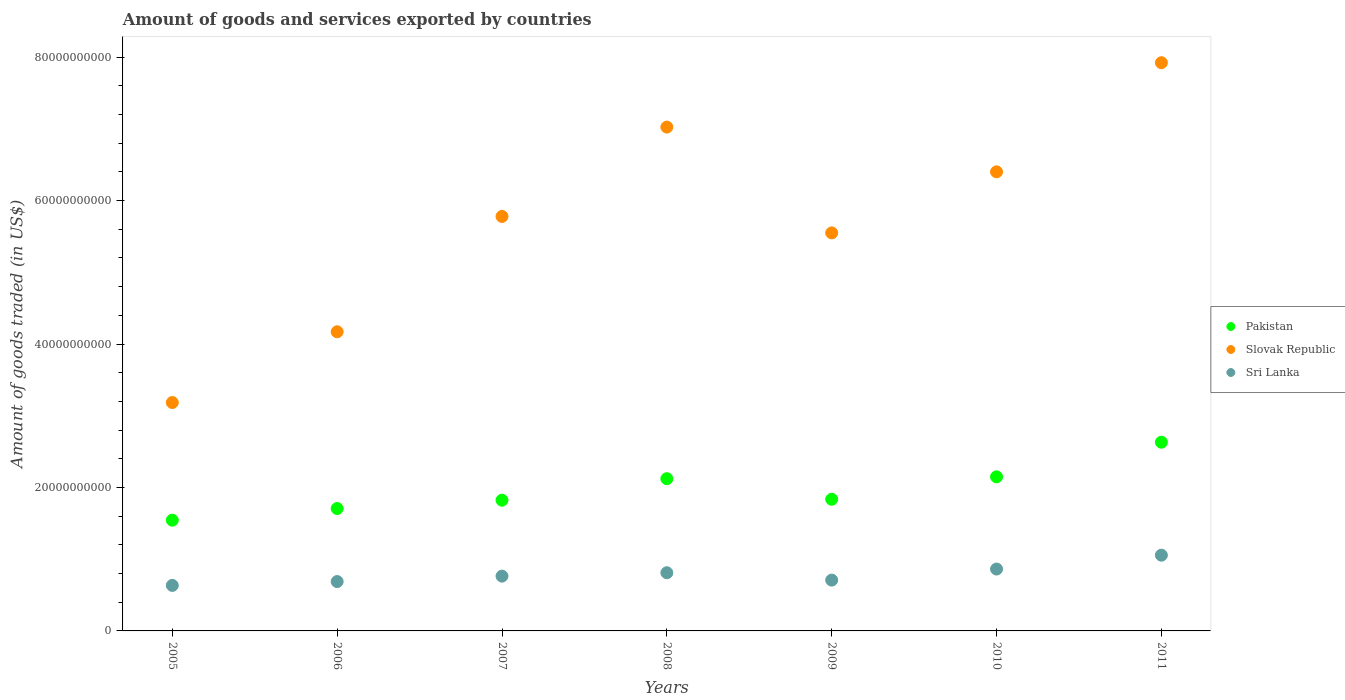How many different coloured dotlines are there?
Ensure brevity in your answer.  3. Is the number of dotlines equal to the number of legend labels?
Make the answer very short. Yes. What is the total amount of goods and services exported in Slovak Republic in 2007?
Provide a succinct answer. 5.78e+1. Across all years, what is the maximum total amount of goods and services exported in Slovak Republic?
Provide a succinct answer. 7.92e+1. Across all years, what is the minimum total amount of goods and services exported in Sri Lanka?
Your answer should be compact. 6.35e+09. In which year was the total amount of goods and services exported in Pakistan maximum?
Your response must be concise. 2011. In which year was the total amount of goods and services exported in Sri Lanka minimum?
Provide a short and direct response. 2005. What is the total total amount of goods and services exported in Sri Lanka in the graph?
Make the answer very short. 5.52e+1. What is the difference between the total amount of goods and services exported in Sri Lanka in 2005 and that in 2010?
Make the answer very short. -2.28e+09. What is the difference between the total amount of goods and services exported in Pakistan in 2008 and the total amount of goods and services exported in Sri Lanka in 2007?
Give a very brief answer. 1.36e+1. What is the average total amount of goods and services exported in Slovak Republic per year?
Offer a terse response. 5.72e+1. In the year 2009, what is the difference between the total amount of goods and services exported in Slovak Republic and total amount of goods and services exported in Pakistan?
Your answer should be compact. 3.71e+1. What is the ratio of the total amount of goods and services exported in Pakistan in 2007 to that in 2008?
Ensure brevity in your answer.  0.86. What is the difference between the highest and the second highest total amount of goods and services exported in Sri Lanka?
Offer a terse response. 1.93e+09. What is the difference between the highest and the lowest total amount of goods and services exported in Slovak Republic?
Provide a succinct answer. 4.74e+1. Is the sum of the total amount of goods and services exported in Slovak Republic in 2008 and 2009 greater than the maximum total amount of goods and services exported in Sri Lanka across all years?
Your answer should be compact. Yes. Is it the case that in every year, the sum of the total amount of goods and services exported in Sri Lanka and total amount of goods and services exported in Pakistan  is greater than the total amount of goods and services exported in Slovak Republic?
Offer a terse response. No. Does the total amount of goods and services exported in Pakistan monotonically increase over the years?
Offer a very short reply. No. Is the total amount of goods and services exported in Sri Lanka strictly less than the total amount of goods and services exported in Slovak Republic over the years?
Provide a succinct answer. Yes. Does the graph contain any zero values?
Offer a very short reply. No. Where does the legend appear in the graph?
Provide a succinct answer. Center right. How many legend labels are there?
Your response must be concise. 3. How are the legend labels stacked?
Ensure brevity in your answer.  Vertical. What is the title of the graph?
Offer a very short reply. Amount of goods and services exported by countries. Does "Puerto Rico" appear as one of the legend labels in the graph?
Your answer should be compact. No. What is the label or title of the X-axis?
Offer a terse response. Years. What is the label or title of the Y-axis?
Offer a terse response. Amount of goods traded (in US$). What is the Amount of goods traded (in US$) in Pakistan in 2005?
Provide a short and direct response. 1.54e+1. What is the Amount of goods traded (in US$) in Slovak Republic in 2005?
Make the answer very short. 3.18e+1. What is the Amount of goods traded (in US$) in Sri Lanka in 2005?
Offer a very short reply. 6.35e+09. What is the Amount of goods traded (in US$) in Pakistan in 2006?
Ensure brevity in your answer.  1.71e+1. What is the Amount of goods traded (in US$) of Slovak Republic in 2006?
Offer a terse response. 4.17e+1. What is the Amount of goods traded (in US$) in Sri Lanka in 2006?
Offer a very short reply. 6.88e+09. What is the Amount of goods traded (in US$) in Pakistan in 2007?
Provide a succinct answer. 1.82e+1. What is the Amount of goods traded (in US$) in Slovak Republic in 2007?
Your answer should be very brief. 5.78e+1. What is the Amount of goods traded (in US$) of Sri Lanka in 2007?
Make the answer very short. 7.64e+09. What is the Amount of goods traded (in US$) in Pakistan in 2008?
Offer a terse response. 2.12e+1. What is the Amount of goods traded (in US$) in Slovak Republic in 2008?
Keep it short and to the point. 7.02e+1. What is the Amount of goods traded (in US$) in Sri Lanka in 2008?
Your answer should be compact. 8.11e+09. What is the Amount of goods traded (in US$) of Pakistan in 2009?
Provide a short and direct response. 1.84e+1. What is the Amount of goods traded (in US$) of Slovak Republic in 2009?
Provide a short and direct response. 5.55e+1. What is the Amount of goods traded (in US$) of Sri Lanka in 2009?
Ensure brevity in your answer.  7.08e+09. What is the Amount of goods traded (in US$) of Pakistan in 2010?
Your answer should be very brief. 2.15e+1. What is the Amount of goods traded (in US$) in Slovak Republic in 2010?
Ensure brevity in your answer.  6.40e+1. What is the Amount of goods traded (in US$) in Sri Lanka in 2010?
Ensure brevity in your answer.  8.63e+09. What is the Amount of goods traded (in US$) in Pakistan in 2011?
Your answer should be very brief. 2.63e+1. What is the Amount of goods traded (in US$) in Slovak Republic in 2011?
Your answer should be compact. 7.92e+1. What is the Amount of goods traded (in US$) of Sri Lanka in 2011?
Your answer should be compact. 1.06e+1. Across all years, what is the maximum Amount of goods traded (in US$) in Pakistan?
Offer a very short reply. 2.63e+1. Across all years, what is the maximum Amount of goods traded (in US$) in Slovak Republic?
Offer a terse response. 7.92e+1. Across all years, what is the maximum Amount of goods traded (in US$) of Sri Lanka?
Offer a terse response. 1.06e+1. Across all years, what is the minimum Amount of goods traded (in US$) in Pakistan?
Ensure brevity in your answer.  1.54e+1. Across all years, what is the minimum Amount of goods traded (in US$) in Slovak Republic?
Give a very brief answer. 3.18e+1. Across all years, what is the minimum Amount of goods traded (in US$) of Sri Lanka?
Offer a very short reply. 6.35e+09. What is the total Amount of goods traded (in US$) of Pakistan in the graph?
Provide a succinct answer. 1.38e+11. What is the total Amount of goods traded (in US$) in Slovak Republic in the graph?
Ensure brevity in your answer.  4.00e+11. What is the total Amount of goods traded (in US$) in Sri Lanka in the graph?
Make the answer very short. 5.52e+1. What is the difference between the Amount of goods traded (in US$) in Pakistan in 2005 and that in 2006?
Your answer should be compact. -1.63e+09. What is the difference between the Amount of goods traded (in US$) in Slovak Republic in 2005 and that in 2006?
Provide a succinct answer. -9.86e+09. What is the difference between the Amount of goods traded (in US$) of Sri Lanka in 2005 and that in 2006?
Make the answer very short. -5.36e+08. What is the difference between the Amount of goods traded (in US$) of Pakistan in 2005 and that in 2007?
Give a very brief answer. -2.79e+09. What is the difference between the Amount of goods traded (in US$) of Slovak Republic in 2005 and that in 2007?
Provide a succinct answer. -2.59e+1. What is the difference between the Amount of goods traded (in US$) of Sri Lanka in 2005 and that in 2007?
Keep it short and to the point. -1.29e+09. What is the difference between the Amount of goods traded (in US$) in Pakistan in 2005 and that in 2008?
Your answer should be very brief. -5.79e+09. What is the difference between the Amount of goods traded (in US$) in Slovak Republic in 2005 and that in 2008?
Make the answer very short. -3.84e+1. What is the difference between the Amount of goods traded (in US$) in Sri Lanka in 2005 and that in 2008?
Offer a terse response. -1.76e+09. What is the difference between the Amount of goods traded (in US$) of Pakistan in 2005 and that in 2009?
Give a very brief answer. -2.92e+09. What is the difference between the Amount of goods traded (in US$) of Slovak Republic in 2005 and that in 2009?
Provide a succinct answer. -2.36e+1. What is the difference between the Amount of goods traded (in US$) in Sri Lanka in 2005 and that in 2009?
Your answer should be very brief. -7.38e+08. What is the difference between the Amount of goods traded (in US$) in Pakistan in 2005 and that in 2010?
Provide a short and direct response. -6.04e+09. What is the difference between the Amount of goods traded (in US$) of Slovak Republic in 2005 and that in 2010?
Give a very brief answer. -3.22e+1. What is the difference between the Amount of goods traded (in US$) of Sri Lanka in 2005 and that in 2010?
Ensure brevity in your answer.  -2.28e+09. What is the difference between the Amount of goods traded (in US$) in Pakistan in 2005 and that in 2011?
Give a very brief answer. -1.09e+1. What is the difference between the Amount of goods traded (in US$) in Slovak Republic in 2005 and that in 2011?
Your answer should be very brief. -4.74e+1. What is the difference between the Amount of goods traded (in US$) in Sri Lanka in 2005 and that in 2011?
Offer a very short reply. -4.21e+09. What is the difference between the Amount of goods traded (in US$) in Pakistan in 2006 and that in 2007?
Give a very brief answer. -1.16e+09. What is the difference between the Amount of goods traded (in US$) of Slovak Republic in 2006 and that in 2007?
Give a very brief answer. -1.61e+1. What is the difference between the Amount of goods traded (in US$) in Sri Lanka in 2006 and that in 2007?
Your answer should be very brief. -7.57e+08. What is the difference between the Amount of goods traded (in US$) of Pakistan in 2006 and that in 2008?
Keep it short and to the point. -4.16e+09. What is the difference between the Amount of goods traded (in US$) in Slovak Republic in 2006 and that in 2008?
Give a very brief answer. -2.85e+1. What is the difference between the Amount of goods traded (in US$) of Sri Lanka in 2006 and that in 2008?
Ensure brevity in your answer.  -1.23e+09. What is the difference between the Amount of goods traded (in US$) of Pakistan in 2006 and that in 2009?
Give a very brief answer. -1.29e+09. What is the difference between the Amount of goods traded (in US$) of Slovak Republic in 2006 and that in 2009?
Ensure brevity in your answer.  -1.38e+1. What is the difference between the Amount of goods traded (in US$) of Sri Lanka in 2006 and that in 2009?
Offer a very short reply. -2.02e+08. What is the difference between the Amount of goods traded (in US$) in Pakistan in 2006 and that in 2010?
Your answer should be compact. -4.42e+09. What is the difference between the Amount of goods traded (in US$) of Slovak Republic in 2006 and that in 2010?
Your response must be concise. -2.23e+1. What is the difference between the Amount of goods traded (in US$) in Sri Lanka in 2006 and that in 2010?
Your answer should be very brief. -1.74e+09. What is the difference between the Amount of goods traded (in US$) of Pakistan in 2006 and that in 2011?
Your answer should be compact. -9.24e+09. What is the difference between the Amount of goods traded (in US$) of Slovak Republic in 2006 and that in 2011?
Make the answer very short. -3.75e+1. What is the difference between the Amount of goods traded (in US$) in Sri Lanka in 2006 and that in 2011?
Your answer should be compact. -3.68e+09. What is the difference between the Amount of goods traded (in US$) of Pakistan in 2007 and that in 2008?
Your response must be concise. -3.00e+09. What is the difference between the Amount of goods traded (in US$) of Slovak Republic in 2007 and that in 2008?
Your response must be concise. -1.25e+1. What is the difference between the Amount of goods traded (in US$) in Sri Lanka in 2007 and that in 2008?
Provide a short and direct response. -4.71e+08. What is the difference between the Amount of goods traded (in US$) of Pakistan in 2007 and that in 2009?
Keep it short and to the point. -1.33e+08. What is the difference between the Amount of goods traded (in US$) of Slovak Republic in 2007 and that in 2009?
Ensure brevity in your answer.  2.30e+09. What is the difference between the Amount of goods traded (in US$) in Sri Lanka in 2007 and that in 2009?
Keep it short and to the point. 5.55e+08. What is the difference between the Amount of goods traded (in US$) in Pakistan in 2007 and that in 2010?
Make the answer very short. -3.26e+09. What is the difference between the Amount of goods traded (in US$) of Slovak Republic in 2007 and that in 2010?
Your response must be concise. -6.22e+09. What is the difference between the Amount of goods traded (in US$) in Sri Lanka in 2007 and that in 2010?
Your answer should be very brief. -9.86e+08. What is the difference between the Amount of goods traded (in US$) in Pakistan in 2007 and that in 2011?
Offer a terse response. -8.08e+09. What is the difference between the Amount of goods traded (in US$) of Slovak Republic in 2007 and that in 2011?
Provide a succinct answer. -2.14e+1. What is the difference between the Amount of goods traded (in US$) of Sri Lanka in 2007 and that in 2011?
Make the answer very short. -2.92e+09. What is the difference between the Amount of goods traded (in US$) of Pakistan in 2008 and that in 2009?
Your answer should be compact. 2.87e+09. What is the difference between the Amount of goods traded (in US$) in Slovak Republic in 2008 and that in 2009?
Keep it short and to the point. 1.48e+1. What is the difference between the Amount of goods traded (in US$) of Sri Lanka in 2008 and that in 2009?
Provide a succinct answer. 1.03e+09. What is the difference between the Amount of goods traded (in US$) in Pakistan in 2008 and that in 2010?
Provide a succinct answer. -2.58e+08. What is the difference between the Amount of goods traded (in US$) of Slovak Republic in 2008 and that in 2010?
Keep it short and to the point. 6.24e+09. What is the difference between the Amount of goods traded (in US$) of Sri Lanka in 2008 and that in 2010?
Your answer should be very brief. -5.15e+08. What is the difference between the Amount of goods traded (in US$) of Pakistan in 2008 and that in 2011?
Provide a succinct answer. -5.08e+09. What is the difference between the Amount of goods traded (in US$) of Slovak Republic in 2008 and that in 2011?
Ensure brevity in your answer.  -8.98e+09. What is the difference between the Amount of goods traded (in US$) in Sri Lanka in 2008 and that in 2011?
Give a very brief answer. -2.45e+09. What is the difference between the Amount of goods traded (in US$) in Pakistan in 2009 and that in 2010?
Provide a short and direct response. -3.12e+09. What is the difference between the Amount of goods traded (in US$) of Slovak Republic in 2009 and that in 2010?
Offer a terse response. -8.51e+09. What is the difference between the Amount of goods traded (in US$) in Sri Lanka in 2009 and that in 2010?
Your answer should be very brief. -1.54e+09. What is the difference between the Amount of goods traded (in US$) of Pakistan in 2009 and that in 2011?
Make the answer very short. -7.95e+09. What is the difference between the Amount of goods traded (in US$) of Slovak Republic in 2009 and that in 2011?
Offer a terse response. -2.37e+1. What is the difference between the Amount of goods traded (in US$) of Sri Lanka in 2009 and that in 2011?
Provide a short and direct response. -3.47e+09. What is the difference between the Amount of goods traded (in US$) of Pakistan in 2010 and that in 2011?
Give a very brief answer. -4.83e+09. What is the difference between the Amount of goods traded (in US$) of Slovak Republic in 2010 and that in 2011?
Offer a very short reply. -1.52e+1. What is the difference between the Amount of goods traded (in US$) in Sri Lanka in 2010 and that in 2011?
Make the answer very short. -1.93e+09. What is the difference between the Amount of goods traded (in US$) of Pakistan in 2005 and the Amount of goods traded (in US$) of Slovak Republic in 2006?
Keep it short and to the point. -2.63e+1. What is the difference between the Amount of goods traded (in US$) of Pakistan in 2005 and the Amount of goods traded (in US$) of Sri Lanka in 2006?
Your answer should be very brief. 8.56e+09. What is the difference between the Amount of goods traded (in US$) of Slovak Republic in 2005 and the Amount of goods traded (in US$) of Sri Lanka in 2006?
Your answer should be very brief. 2.50e+1. What is the difference between the Amount of goods traded (in US$) in Pakistan in 2005 and the Amount of goods traded (in US$) in Slovak Republic in 2007?
Provide a succinct answer. -4.23e+1. What is the difference between the Amount of goods traded (in US$) of Pakistan in 2005 and the Amount of goods traded (in US$) of Sri Lanka in 2007?
Keep it short and to the point. 7.80e+09. What is the difference between the Amount of goods traded (in US$) of Slovak Republic in 2005 and the Amount of goods traded (in US$) of Sri Lanka in 2007?
Give a very brief answer. 2.42e+1. What is the difference between the Amount of goods traded (in US$) in Pakistan in 2005 and the Amount of goods traded (in US$) in Slovak Republic in 2008?
Offer a very short reply. -5.48e+1. What is the difference between the Amount of goods traded (in US$) of Pakistan in 2005 and the Amount of goods traded (in US$) of Sri Lanka in 2008?
Give a very brief answer. 7.33e+09. What is the difference between the Amount of goods traded (in US$) in Slovak Republic in 2005 and the Amount of goods traded (in US$) in Sri Lanka in 2008?
Offer a terse response. 2.37e+1. What is the difference between the Amount of goods traded (in US$) in Pakistan in 2005 and the Amount of goods traded (in US$) in Slovak Republic in 2009?
Your answer should be compact. -4.01e+1. What is the difference between the Amount of goods traded (in US$) in Pakistan in 2005 and the Amount of goods traded (in US$) in Sri Lanka in 2009?
Your answer should be very brief. 8.35e+09. What is the difference between the Amount of goods traded (in US$) of Slovak Republic in 2005 and the Amount of goods traded (in US$) of Sri Lanka in 2009?
Make the answer very short. 2.48e+1. What is the difference between the Amount of goods traded (in US$) in Pakistan in 2005 and the Amount of goods traded (in US$) in Slovak Republic in 2010?
Offer a very short reply. -4.86e+1. What is the difference between the Amount of goods traded (in US$) in Pakistan in 2005 and the Amount of goods traded (in US$) in Sri Lanka in 2010?
Offer a terse response. 6.81e+09. What is the difference between the Amount of goods traded (in US$) of Slovak Republic in 2005 and the Amount of goods traded (in US$) of Sri Lanka in 2010?
Ensure brevity in your answer.  2.32e+1. What is the difference between the Amount of goods traded (in US$) of Pakistan in 2005 and the Amount of goods traded (in US$) of Slovak Republic in 2011?
Your response must be concise. -6.38e+1. What is the difference between the Amount of goods traded (in US$) in Pakistan in 2005 and the Amount of goods traded (in US$) in Sri Lanka in 2011?
Provide a succinct answer. 4.88e+09. What is the difference between the Amount of goods traded (in US$) of Slovak Republic in 2005 and the Amount of goods traded (in US$) of Sri Lanka in 2011?
Your response must be concise. 2.13e+1. What is the difference between the Amount of goods traded (in US$) of Pakistan in 2006 and the Amount of goods traded (in US$) of Slovak Republic in 2007?
Provide a short and direct response. -4.07e+1. What is the difference between the Amount of goods traded (in US$) in Pakistan in 2006 and the Amount of goods traded (in US$) in Sri Lanka in 2007?
Provide a short and direct response. 9.42e+09. What is the difference between the Amount of goods traded (in US$) in Slovak Republic in 2006 and the Amount of goods traded (in US$) in Sri Lanka in 2007?
Give a very brief answer. 3.41e+1. What is the difference between the Amount of goods traded (in US$) in Pakistan in 2006 and the Amount of goods traded (in US$) in Slovak Republic in 2008?
Your answer should be compact. -5.32e+1. What is the difference between the Amount of goods traded (in US$) in Pakistan in 2006 and the Amount of goods traded (in US$) in Sri Lanka in 2008?
Your response must be concise. 8.95e+09. What is the difference between the Amount of goods traded (in US$) in Slovak Republic in 2006 and the Amount of goods traded (in US$) in Sri Lanka in 2008?
Your answer should be very brief. 3.36e+1. What is the difference between the Amount of goods traded (in US$) of Pakistan in 2006 and the Amount of goods traded (in US$) of Slovak Republic in 2009?
Offer a very short reply. -3.84e+1. What is the difference between the Amount of goods traded (in US$) of Pakistan in 2006 and the Amount of goods traded (in US$) of Sri Lanka in 2009?
Provide a succinct answer. 9.98e+09. What is the difference between the Amount of goods traded (in US$) of Slovak Republic in 2006 and the Amount of goods traded (in US$) of Sri Lanka in 2009?
Offer a very short reply. 3.46e+1. What is the difference between the Amount of goods traded (in US$) of Pakistan in 2006 and the Amount of goods traded (in US$) of Slovak Republic in 2010?
Give a very brief answer. -4.69e+1. What is the difference between the Amount of goods traded (in US$) in Pakistan in 2006 and the Amount of goods traded (in US$) in Sri Lanka in 2010?
Provide a short and direct response. 8.44e+09. What is the difference between the Amount of goods traded (in US$) of Slovak Republic in 2006 and the Amount of goods traded (in US$) of Sri Lanka in 2010?
Give a very brief answer. 3.31e+1. What is the difference between the Amount of goods traded (in US$) of Pakistan in 2006 and the Amount of goods traded (in US$) of Slovak Republic in 2011?
Ensure brevity in your answer.  -6.22e+1. What is the difference between the Amount of goods traded (in US$) of Pakistan in 2006 and the Amount of goods traded (in US$) of Sri Lanka in 2011?
Offer a very short reply. 6.51e+09. What is the difference between the Amount of goods traded (in US$) in Slovak Republic in 2006 and the Amount of goods traded (in US$) in Sri Lanka in 2011?
Provide a succinct answer. 3.11e+1. What is the difference between the Amount of goods traded (in US$) of Pakistan in 2007 and the Amount of goods traded (in US$) of Slovak Republic in 2008?
Your response must be concise. -5.20e+1. What is the difference between the Amount of goods traded (in US$) in Pakistan in 2007 and the Amount of goods traded (in US$) in Sri Lanka in 2008?
Keep it short and to the point. 1.01e+1. What is the difference between the Amount of goods traded (in US$) of Slovak Republic in 2007 and the Amount of goods traded (in US$) of Sri Lanka in 2008?
Offer a very short reply. 4.97e+1. What is the difference between the Amount of goods traded (in US$) in Pakistan in 2007 and the Amount of goods traded (in US$) in Slovak Republic in 2009?
Your answer should be very brief. -3.73e+1. What is the difference between the Amount of goods traded (in US$) of Pakistan in 2007 and the Amount of goods traded (in US$) of Sri Lanka in 2009?
Keep it short and to the point. 1.11e+1. What is the difference between the Amount of goods traded (in US$) in Slovak Republic in 2007 and the Amount of goods traded (in US$) in Sri Lanka in 2009?
Your response must be concise. 5.07e+1. What is the difference between the Amount of goods traded (in US$) in Pakistan in 2007 and the Amount of goods traded (in US$) in Slovak Republic in 2010?
Offer a very short reply. -4.58e+1. What is the difference between the Amount of goods traded (in US$) of Pakistan in 2007 and the Amount of goods traded (in US$) of Sri Lanka in 2010?
Your answer should be compact. 9.60e+09. What is the difference between the Amount of goods traded (in US$) of Slovak Republic in 2007 and the Amount of goods traded (in US$) of Sri Lanka in 2010?
Provide a short and direct response. 4.92e+1. What is the difference between the Amount of goods traded (in US$) of Pakistan in 2007 and the Amount of goods traded (in US$) of Slovak Republic in 2011?
Offer a very short reply. -6.10e+1. What is the difference between the Amount of goods traded (in US$) in Pakistan in 2007 and the Amount of goods traded (in US$) in Sri Lanka in 2011?
Your answer should be compact. 7.67e+09. What is the difference between the Amount of goods traded (in US$) of Slovak Republic in 2007 and the Amount of goods traded (in US$) of Sri Lanka in 2011?
Your answer should be very brief. 4.72e+1. What is the difference between the Amount of goods traded (in US$) in Pakistan in 2008 and the Amount of goods traded (in US$) in Slovak Republic in 2009?
Keep it short and to the point. -3.43e+1. What is the difference between the Amount of goods traded (in US$) in Pakistan in 2008 and the Amount of goods traded (in US$) in Sri Lanka in 2009?
Offer a terse response. 1.41e+1. What is the difference between the Amount of goods traded (in US$) in Slovak Republic in 2008 and the Amount of goods traded (in US$) in Sri Lanka in 2009?
Keep it short and to the point. 6.32e+1. What is the difference between the Amount of goods traded (in US$) in Pakistan in 2008 and the Amount of goods traded (in US$) in Slovak Republic in 2010?
Your answer should be very brief. -4.28e+1. What is the difference between the Amount of goods traded (in US$) in Pakistan in 2008 and the Amount of goods traded (in US$) in Sri Lanka in 2010?
Your answer should be compact. 1.26e+1. What is the difference between the Amount of goods traded (in US$) in Slovak Republic in 2008 and the Amount of goods traded (in US$) in Sri Lanka in 2010?
Provide a short and direct response. 6.16e+1. What is the difference between the Amount of goods traded (in US$) in Pakistan in 2008 and the Amount of goods traded (in US$) in Slovak Republic in 2011?
Ensure brevity in your answer.  -5.80e+1. What is the difference between the Amount of goods traded (in US$) of Pakistan in 2008 and the Amount of goods traded (in US$) of Sri Lanka in 2011?
Your answer should be compact. 1.07e+1. What is the difference between the Amount of goods traded (in US$) of Slovak Republic in 2008 and the Amount of goods traded (in US$) of Sri Lanka in 2011?
Provide a short and direct response. 5.97e+1. What is the difference between the Amount of goods traded (in US$) in Pakistan in 2009 and the Amount of goods traded (in US$) in Slovak Republic in 2010?
Give a very brief answer. -4.56e+1. What is the difference between the Amount of goods traded (in US$) in Pakistan in 2009 and the Amount of goods traded (in US$) in Sri Lanka in 2010?
Your response must be concise. 9.73e+09. What is the difference between the Amount of goods traded (in US$) in Slovak Republic in 2009 and the Amount of goods traded (in US$) in Sri Lanka in 2010?
Offer a terse response. 4.69e+1. What is the difference between the Amount of goods traded (in US$) in Pakistan in 2009 and the Amount of goods traded (in US$) in Slovak Republic in 2011?
Keep it short and to the point. -6.09e+1. What is the difference between the Amount of goods traded (in US$) in Pakistan in 2009 and the Amount of goods traded (in US$) in Sri Lanka in 2011?
Provide a short and direct response. 7.80e+09. What is the difference between the Amount of goods traded (in US$) in Slovak Republic in 2009 and the Amount of goods traded (in US$) in Sri Lanka in 2011?
Provide a succinct answer. 4.49e+1. What is the difference between the Amount of goods traded (in US$) of Pakistan in 2010 and the Amount of goods traded (in US$) of Slovak Republic in 2011?
Offer a very short reply. -5.77e+1. What is the difference between the Amount of goods traded (in US$) in Pakistan in 2010 and the Amount of goods traded (in US$) in Sri Lanka in 2011?
Your response must be concise. 1.09e+1. What is the difference between the Amount of goods traded (in US$) of Slovak Republic in 2010 and the Amount of goods traded (in US$) of Sri Lanka in 2011?
Give a very brief answer. 5.34e+1. What is the average Amount of goods traded (in US$) of Pakistan per year?
Ensure brevity in your answer.  1.97e+1. What is the average Amount of goods traded (in US$) of Slovak Republic per year?
Your answer should be compact. 5.72e+1. What is the average Amount of goods traded (in US$) in Sri Lanka per year?
Your answer should be compact. 7.89e+09. In the year 2005, what is the difference between the Amount of goods traded (in US$) of Pakistan and Amount of goods traded (in US$) of Slovak Republic?
Keep it short and to the point. -1.64e+1. In the year 2005, what is the difference between the Amount of goods traded (in US$) in Pakistan and Amount of goods traded (in US$) in Sri Lanka?
Give a very brief answer. 9.09e+09. In the year 2005, what is the difference between the Amount of goods traded (in US$) of Slovak Republic and Amount of goods traded (in US$) of Sri Lanka?
Offer a very short reply. 2.55e+1. In the year 2006, what is the difference between the Amount of goods traded (in US$) in Pakistan and Amount of goods traded (in US$) in Slovak Republic?
Offer a very short reply. -2.46e+1. In the year 2006, what is the difference between the Amount of goods traded (in US$) in Pakistan and Amount of goods traded (in US$) in Sri Lanka?
Offer a terse response. 1.02e+1. In the year 2006, what is the difference between the Amount of goods traded (in US$) of Slovak Republic and Amount of goods traded (in US$) of Sri Lanka?
Your answer should be very brief. 3.48e+1. In the year 2007, what is the difference between the Amount of goods traded (in US$) of Pakistan and Amount of goods traded (in US$) of Slovak Republic?
Your answer should be compact. -3.96e+1. In the year 2007, what is the difference between the Amount of goods traded (in US$) in Pakistan and Amount of goods traded (in US$) in Sri Lanka?
Provide a short and direct response. 1.06e+1. In the year 2007, what is the difference between the Amount of goods traded (in US$) in Slovak Republic and Amount of goods traded (in US$) in Sri Lanka?
Offer a terse response. 5.01e+1. In the year 2008, what is the difference between the Amount of goods traded (in US$) in Pakistan and Amount of goods traded (in US$) in Slovak Republic?
Make the answer very short. -4.90e+1. In the year 2008, what is the difference between the Amount of goods traded (in US$) of Pakistan and Amount of goods traded (in US$) of Sri Lanka?
Your answer should be very brief. 1.31e+1. In the year 2008, what is the difference between the Amount of goods traded (in US$) of Slovak Republic and Amount of goods traded (in US$) of Sri Lanka?
Your answer should be compact. 6.21e+1. In the year 2009, what is the difference between the Amount of goods traded (in US$) of Pakistan and Amount of goods traded (in US$) of Slovak Republic?
Ensure brevity in your answer.  -3.71e+1. In the year 2009, what is the difference between the Amount of goods traded (in US$) in Pakistan and Amount of goods traded (in US$) in Sri Lanka?
Provide a short and direct response. 1.13e+1. In the year 2009, what is the difference between the Amount of goods traded (in US$) in Slovak Republic and Amount of goods traded (in US$) in Sri Lanka?
Keep it short and to the point. 4.84e+1. In the year 2010, what is the difference between the Amount of goods traded (in US$) in Pakistan and Amount of goods traded (in US$) in Slovak Republic?
Your answer should be very brief. -4.25e+1. In the year 2010, what is the difference between the Amount of goods traded (in US$) in Pakistan and Amount of goods traded (in US$) in Sri Lanka?
Keep it short and to the point. 1.29e+1. In the year 2010, what is the difference between the Amount of goods traded (in US$) of Slovak Republic and Amount of goods traded (in US$) of Sri Lanka?
Your answer should be very brief. 5.54e+1. In the year 2011, what is the difference between the Amount of goods traded (in US$) of Pakistan and Amount of goods traded (in US$) of Slovak Republic?
Your response must be concise. -5.29e+1. In the year 2011, what is the difference between the Amount of goods traded (in US$) of Pakistan and Amount of goods traded (in US$) of Sri Lanka?
Keep it short and to the point. 1.57e+1. In the year 2011, what is the difference between the Amount of goods traded (in US$) of Slovak Republic and Amount of goods traded (in US$) of Sri Lanka?
Your answer should be compact. 6.87e+1. What is the ratio of the Amount of goods traded (in US$) in Pakistan in 2005 to that in 2006?
Your answer should be compact. 0.9. What is the ratio of the Amount of goods traded (in US$) of Slovak Republic in 2005 to that in 2006?
Provide a short and direct response. 0.76. What is the ratio of the Amount of goods traded (in US$) in Sri Lanka in 2005 to that in 2006?
Your response must be concise. 0.92. What is the ratio of the Amount of goods traded (in US$) of Pakistan in 2005 to that in 2007?
Offer a very short reply. 0.85. What is the ratio of the Amount of goods traded (in US$) in Slovak Republic in 2005 to that in 2007?
Keep it short and to the point. 0.55. What is the ratio of the Amount of goods traded (in US$) in Sri Lanka in 2005 to that in 2007?
Offer a very short reply. 0.83. What is the ratio of the Amount of goods traded (in US$) in Pakistan in 2005 to that in 2008?
Offer a very short reply. 0.73. What is the ratio of the Amount of goods traded (in US$) of Slovak Republic in 2005 to that in 2008?
Offer a terse response. 0.45. What is the ratio of the Amount of goods traded (in US$) of Sri Lanka in 2005 to that in 2008?
Offer a terse response. 0.78. What is the ratio of the Amount of goods traded (in US$) in Pakistan in 2005 to that in 2009?
Ensure brevity in your answer.  0.84. What is the ratio of the Amount of goods traded (in US$) of Slovak Republic in 2005 to that in 2009?
Keep it short and to the point. 0.57. What is the ratio of the Amount of goods traded (in US$) of Sri Lanka in 2005 to that in 2009?
Offer a very short reply. 0.9. What is the ratio of the Amount of goods traded (in US$) of Pakistan in 2005 to that in 2010?
Make the answer very short. 0.72. What is the ratio of the Amount of goods traded (in US$) in Slovak Republic in 2005 to that in 2010?
Your answer should be compact. 0.5. What is the ratio of the Amount of goods traded (in US$) in Sri Lanka in 2005 to that in 2010?
Your answer should be very brief. 0.74. What is the ratio of the Amount of goods traded (in US$) of Pakistan in 2005 to that in 2011?
Give a very brief answer. 0.59. What is the ratio of the Amount of goods traded (in US$) of Slovak Republic in 2005 to that in 2011?
Give a very brief answer. 0.4. What is the ratio of the Amount of goods traded (in US$) in Sri Lanka in 2005 to that in 2011?
Give a very brief answer. 0.6. What is the ratio of the Amount of goods traded (in US$) of Pakistan in 2006 to that in 2007?
Your answer should be very brief. 0.94. What is the ratio of the Amount of goods traded (in US$) of Slovak Republic in 2006 to that in 2007?
Your response must be concise. 0.72. What is the ratio of the Amount of goods traded (in US$) in Sri Lanka in 2006 to that in 2007?
Your response must be concise. 0.9. What is the ratio of the Amount of goods traded (in US$) of Pakistan in 2006 to that in 2008?
Make the answer very short. 0.8. What is the ratio of the Amount of goods traded (in US$) in Slovak Republic in 2006 to that in 2008?
Make the answer very short. 0.59. What is the ratio of the Amount of goods traded (in US$) of Sri Lanka in 2006 to that in 2008?
Provide a short and direct response. 0.85. What is the ratio of the Amount of goods traded (in US$) in Pakistan in 2006 to that in 2009?
Your answer should be very brief. 0.93. What is the ratio of the Amount of goods traded (in US$) in Slovak Republic in 2006 to that in 2009?
Offer a very short reply. 0.75. What is the ratio of the Amount of goods traded (in US$) in Sri Lanka in 2006 to that in 2009?
Your answer should be compact. 0.97. What is the ratio of the Amount of goods traded (in US$) in Pakistan in 2006 to that in 2010?
Offer a very short reply. 0.79. What is the ratio of the Amount of goods traded (in US$) of Slovak Republic in 2006 to that in 2010?
Provide a succinct answer. 0.65. What is the ratio of the Amount of goods traded (in US$) of Sri Lanka in 2006 to that in 2010?
Your answer should be compact. 0.8. What is the ratio of the Amount of goods traded (in US$) in Pakistan in 2006 to that in 2011?
Give a very brief answer. 0.65. What is the ratio of the Amount of goods traded (in US$) in Slovak Republic in 2006 to that in 2011?
Offer a very short reply. 0.53. What is the ratio of the Amount of goods traded (in US$) in Sri Lanka in 2006 to that in 2011?
Ensure brevity in your answer.  0.65. What is the ratio of the Amount of goods traded (in US$) of Pakistan in 2007 to that in 2008?
Give a very brief answer. 0.86. What is the ratio of the Amount of goods traded (in US$) in Slovak Republic in 2007 to that in 2008?
Your answer should be very brief. 0.82. What is the ratio of the Amount of goods traded (in US$) of Sri Lanka in 2007 to that in 2008?
Keep it short and to the point. 0.94. What is the ratio of the Amount of goods traded (in US$) of Slovak Republic in 2007 to that in 2009?
Provide a short and direct response. 1.04. What is the ratio of the Amount of goods traded (in US$) in Sri Lanka in 2007 to that in 2009?
Offer a terse response. 1.08. What is the ratio of the Amount of goods traded (in US$) of Pakistan in 2007 to that in 2010?
Offer a terse response. 0.85. What is the ratio of the Amount of goods traded (in US$) in Slovak Republic in 2007 to that in 2010?
Give a very brief answer. 0.9. What is the ratio of the Amount of goods traded (in US$) in Sri Lanka in 2007 to that in 2010?
Your response must be concise. 0.89. What is the ratio of the Amount of goods traded (in US$) of Pakistan in 2007 to that in 2011?
Ensure brevity in your answer.  0.69. What is the ratio of the Amount of goods traded (in US$) of Slovak Republic in 2007 to that in 2011?
Your answer should be compact. 0.73. What is the ratio of the Amount of goods traded (in US$) in Sri Lanka in 2007 to that in 2011?
Offer a very short reply. 0.72. What is the ratio of the Amount of goods traded (in US$) in Pakistan in 2008 to that in 2009?
Provide a short and direct response. 1.16. What is the ratio of the Amount of goods traded (in US$) of Slovak Republic in 2008 to that in 2009?
Give a very brief answer. 1.27. What is the ratio of the Amount of goods traded (in US$) in Sri Lanka in 2008 to that in 2009?
Give a very brief answer. 1.14. What is the ratio of the Amount of goods traded (in US$) in Slovak Republic in 2008 to that in 2010?
Make the answer very short. 1.1. What is the ratio of the Amount of goods traded (in US$) in Sri Lanka in 2008 to that in 2010?
Provide a succinct answer. 0.94. What is the ratio of the Amount of goods traded (in US$) in Pakistan in 2008 to that in 2011?
Your response must be concise. 0.81. What is the ratio of the Amount of goods traded (in US$) of Slovak Republic in 2008 to that in 2011?
Offer a terse response. 0.89. What is the ratio of the Amount of goods traded (in US$) in Sri Lanka in 2008 to that in 2011?
Keep it short and to the point. 0.77. What is the ratio of the Amount of goods traded (in US$) of Pakistan in 2009 to that in 2010?
Offer a very short reply. 0.85. What is the ratio of the Amount of goods traded (in US$) of Slovak Republic in 2009 to that in 2010?
Keep it short and to the point. 0.87. What is the ratio of the Amount of goods traded (in US$) in Sri Lanka in 2009 to that in 2010?
Your answer should be very brief. 0.82. What is the ratio of the Amount of goods traded (in US$) of Pakistan in 2009 to that in 2011?
Keep it short and to the point. 0.7. What is the ratio of the Amount of goods traded (in US$) in Slovak Republic in 2009 to that in 2011?
Offer a terse response. 0.7. What is the ratio of the Amount of goods traded (in US$) in Sri Lanka in 2009 to that in 2011?
Make the answer very short. 0.67. What is the ratio of the Amount of goods traded (in US$) of Pakistan in 2010 to that in 2011?
Keep it short and to the point. 0.82. What is the ratio of the Amount of goods traded (in US$) in Slovak Republic in 2010 to that in 2011?
Ensure brevity in your answer.  0.81. What is the ratio of the Amount of goods traded (in US$) of Sri Lanka in 2010 to that in 2011?
Your response must be concise. 0.82. What is the difference between the highest and the second highest Amount of goods traded (in US$) in Pakistan?
Keep it short and to the point. 4.83e+09. What is the difference between the highest and the second highest Amount of goods traded (in US$) in Slovak Republic?
Give a very brief answer. 8.98e+09. What is the difference between the highest and the second highest Amount of goods traded (in US$) in Sri Lanka?
Your answer should be compact. 1.93e+09. What is the difference between the highest and the lowest Amount of goods traded (in US$) in Pakistan?
Keep it short and to the point. 1.09e+1. What is the difference between the highest and the lowest Amount of goods traded (in US$) of Slovak Republic?
Make the answer very short. 4.74e+1. What is the difference between the highest and the lowest Amount of goods traded (in US$) of Sri Lanka?
Your response must be concise. 4.21e+09. 